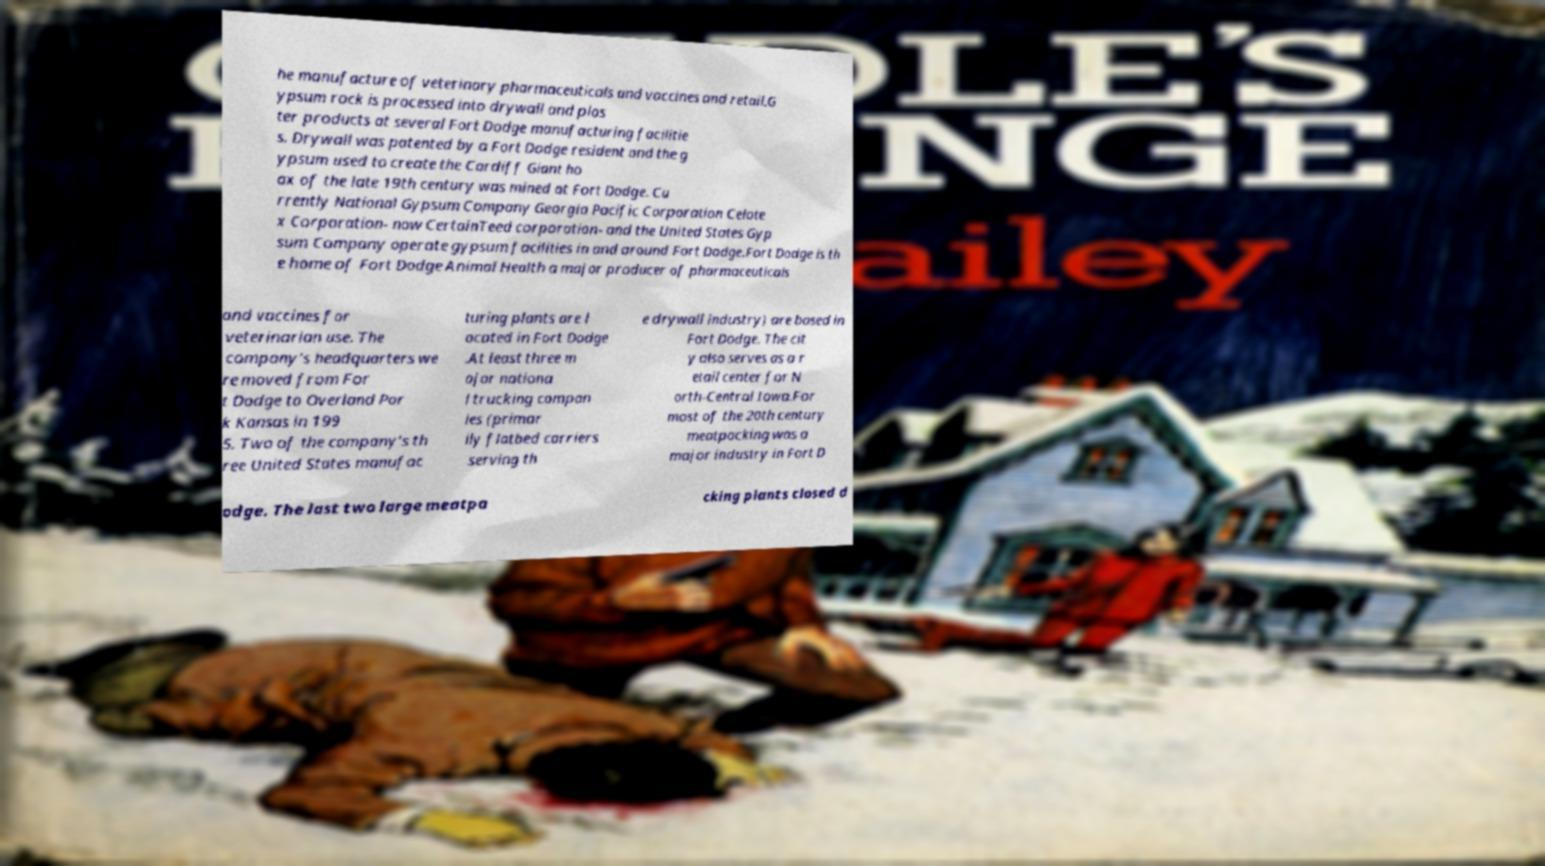For documentation purposes, I need the text within this image transcribed. Could you provide that? he manufacture of veterinary pharmaceuticals and vaccines and retail.G ypsum rock is processed into drywall and plas ter products at several Fort Dodge manufacturing facilitie s. Drywall was patented by a Fort Dodge resident and the g ypsum used to create the Cardiff Giant ho ax of the late 19th century was mined at Fort Dodge. Cu rrently National Gypsum Company Georgia Pacific Corporation Celote x Corporation- now CertainTeed corporation- and the United States Gyp sum Company operate gypsum facilities in and around Fort Dodge.Fort Dodge is th e home of Fort Dodge Animal Health a major producer of pharmaceuticals and vaccines for veterinarian use. The company's headquarters we re moved from For t Dodge to Overland Par k Kansas in 199 5. Two of the company's th ree United States manufac turing plants are l ocated in Fort Dodge .At least three m ajor nationa l trucking compan ies (primar ily flatbed carriers serving th e drywall industry) are based in Fort Dodge. The cit y also serves as a r etail center for N orth-Central Iowa.For most of the 20th century meatpacking was a major industry in Fort D odge. The last two large meatpa cking plants closed d 